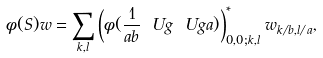<formula> <loc_0><loc_0><loc_500><loc_500>\phi ( S ) w = \sum _ { k , l } \left ( \phi ( \frac { 1 } { a b } \ U g \ U g a ) \right ) ^ { \ast } _ { 0 , 0 ; k , l } w _ { k / b , l / a } ,</formula> 